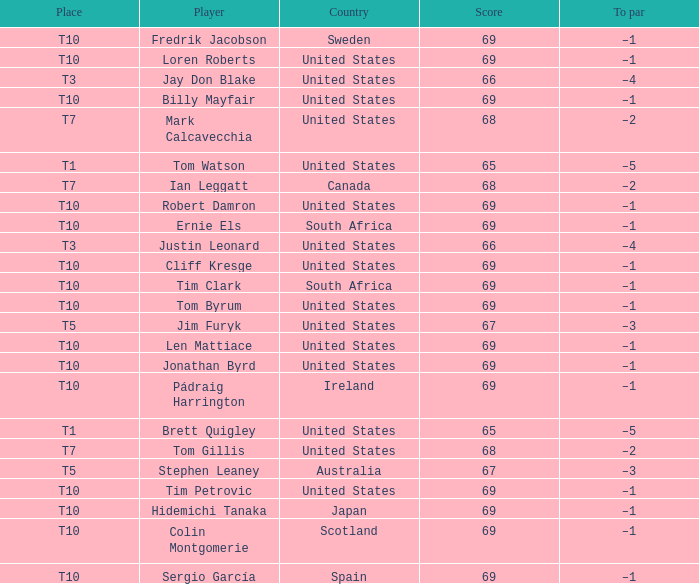What is the average score for the player who is T5 in the United States? 67.0. 